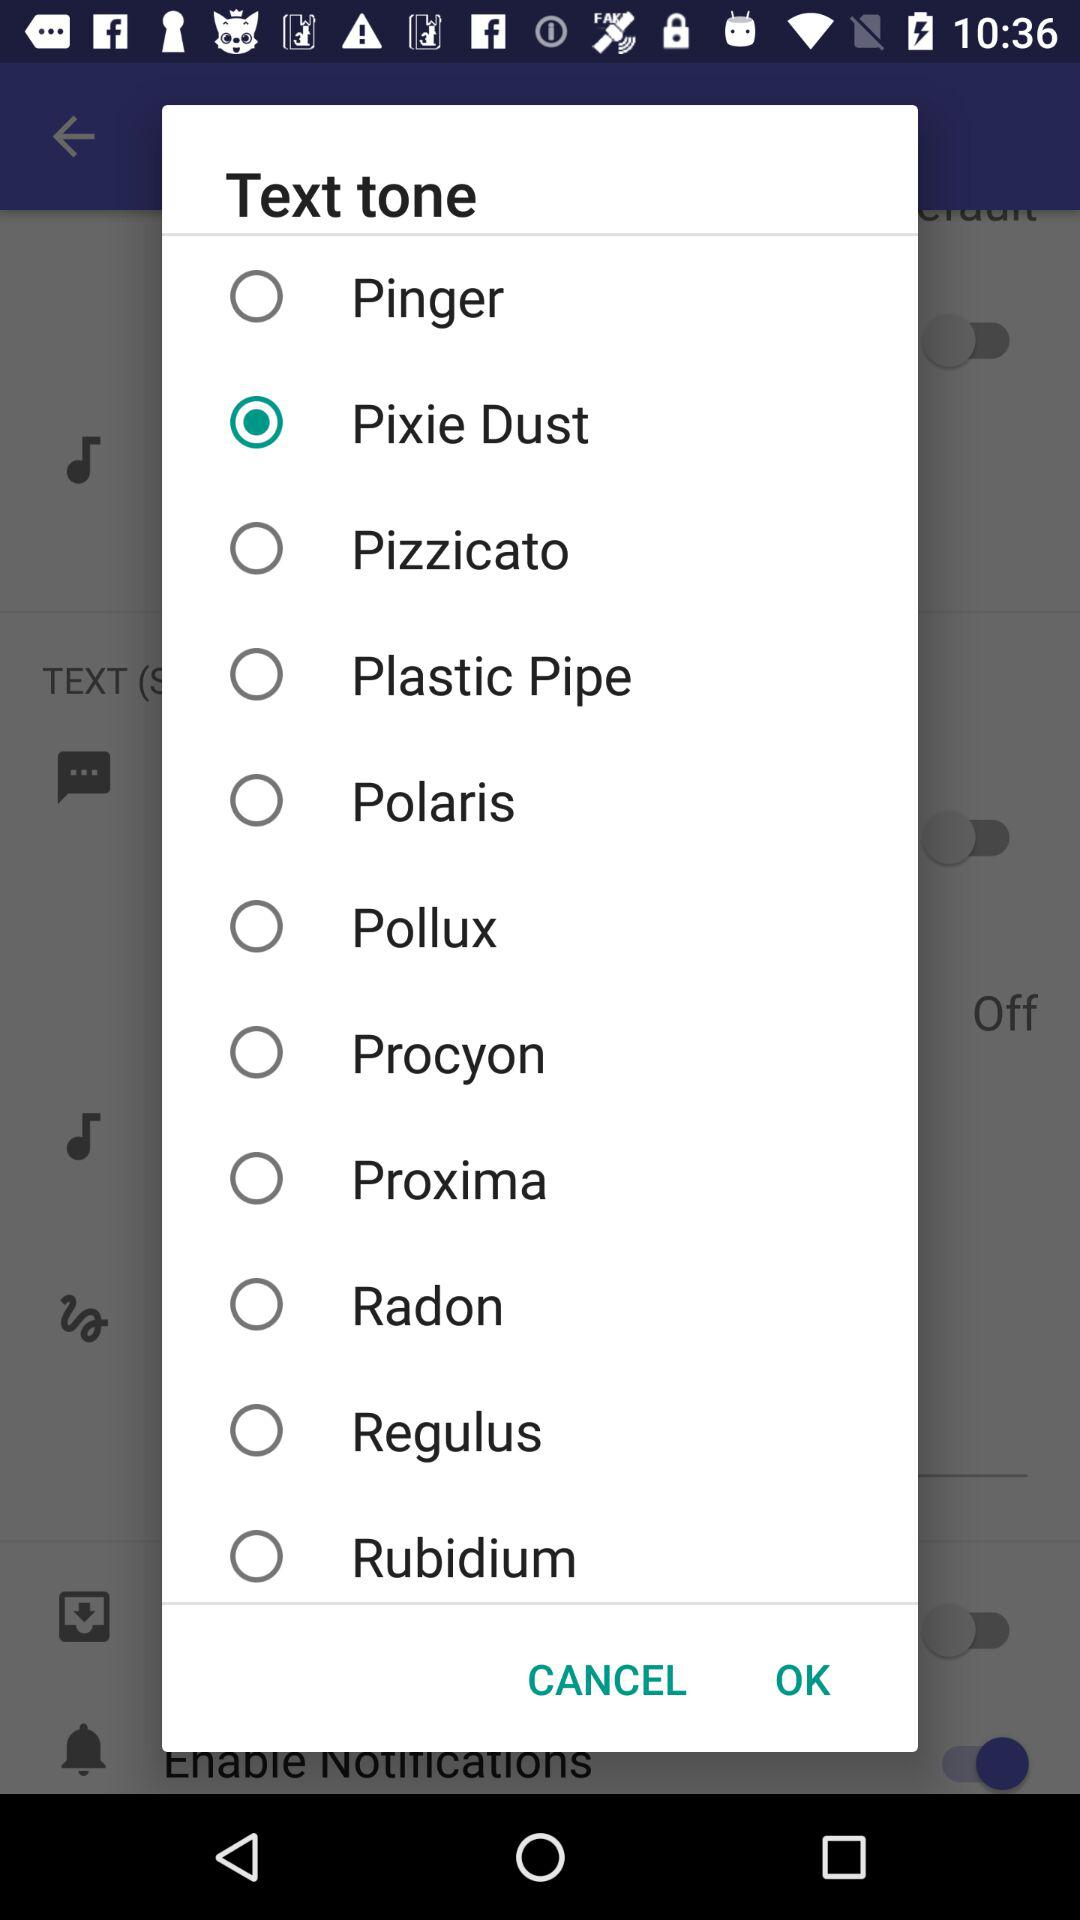What are the various text tones that are accessible here? The various text tones are "Pinger", "Pixie Dust", "Pizzicato", "Plastic Pipe", "Polaris", "Pollux", "Procyon", "Proxima", "Radon", "Regulus" and "Rubidium". 